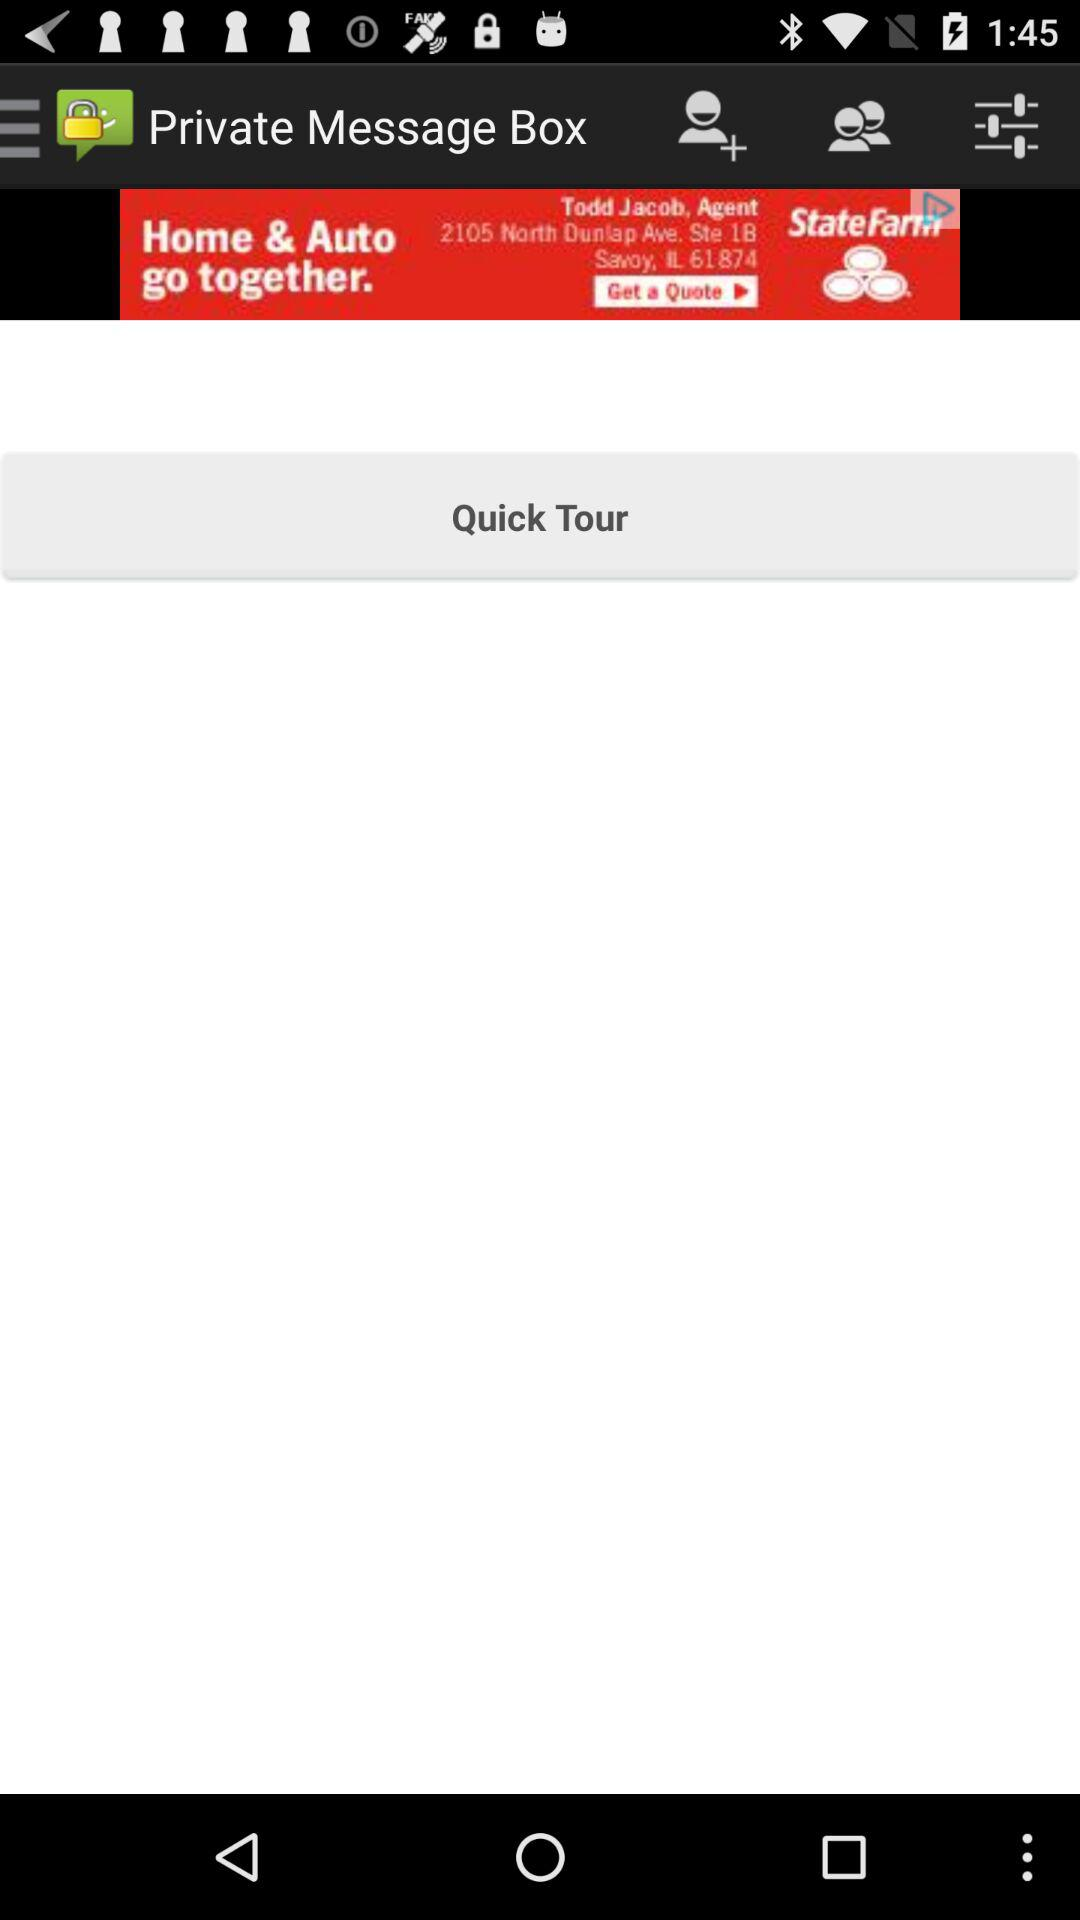What is the name of the application? The name of the application is "Private Message Box". 